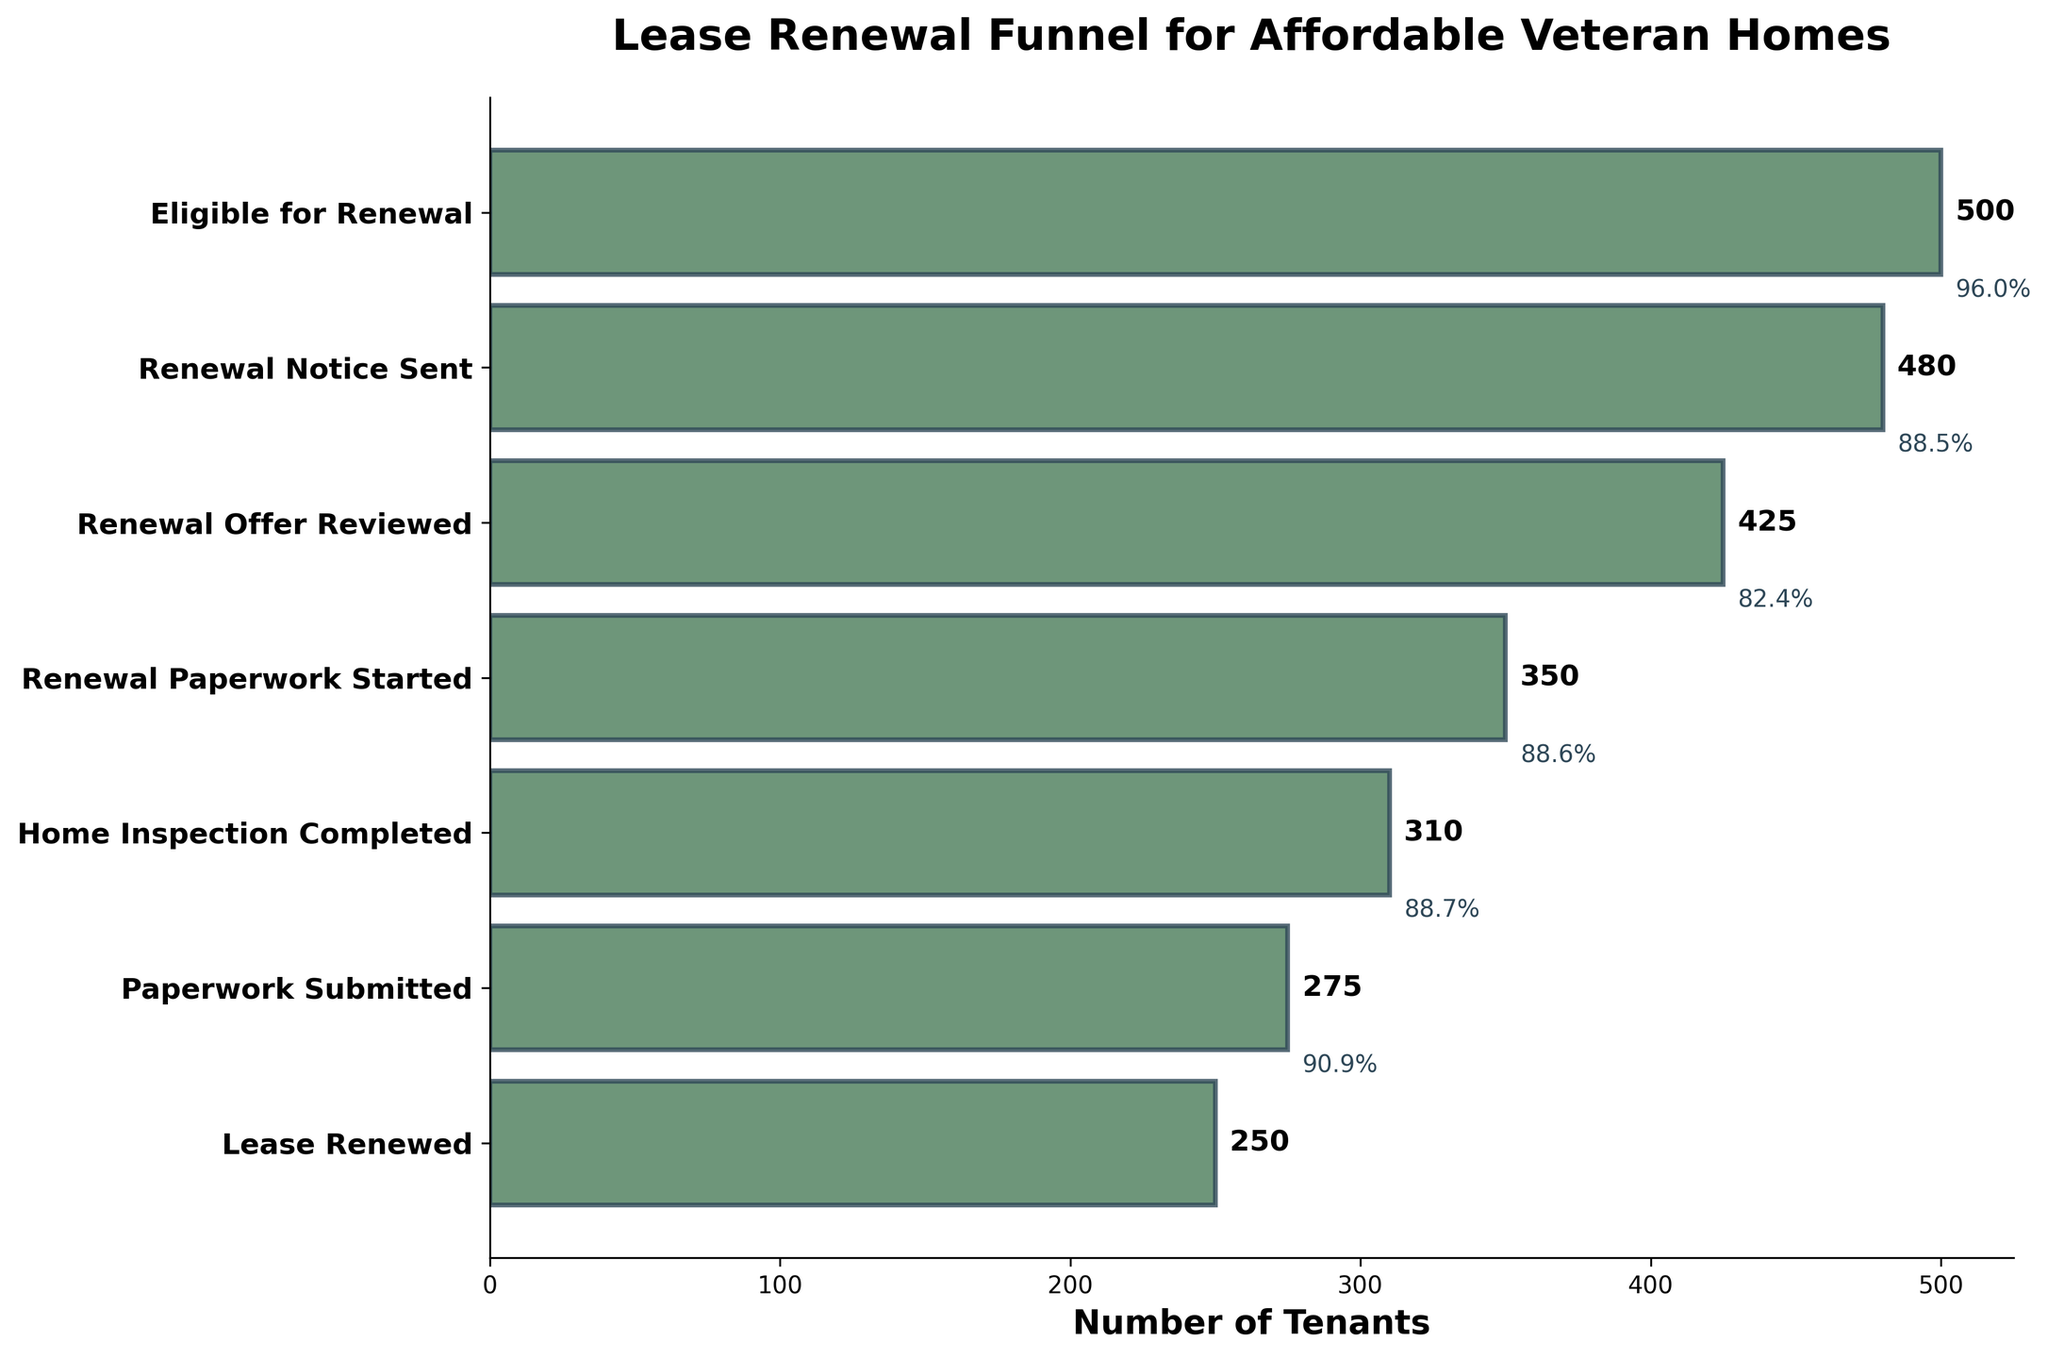What's the title of the figure? The title is usually displayed at the top of the figure. In this case, it reads "Lease Renewal Funnel for Affordable Veteran Homes" based on the provided code.
Answer: Lease Renewal Funnel for Affordable Veteran Homes How many tenants started the renewal paperwork? The figure shows multiple stages with the number of tenants in each stage. The number for "Renewal Paperwork Started" can be found and identified as 350 tenants.
Answer: 350 How many tenants received a renewal notice? The figure lists "Renewal Notice Sent" as one of the stages. The number of tenants at this stage is shown as 480.
Answer: 480 What percentage of eligible tenants had their paperwork submitted? Calculate the percentage by dividing the number of tenants who submitted paperwork by the number of eligible tenants and then multiplying by 100. (275 / 500) * 100 = 55%
Answer: 55% What is the decrease in the number of tenants between the "Home Inspection Completed" and "Paperwork Submitted" stages? To find the decrease, subtract the number of tenants who submitted paperwork from the number who completed the home inspection: 310 - 275 = 35.
Answer: 35 Which stage saw the highest drop-off in the number of tenants from the previous stage? Compare the differences between each consecutive stage: Eligible for Renewal to Renewal Notice Sent (20), Renewal Notice Sent to Renewal Offer Reviewed (55), etc. The largest drop from one stage to the next can be seen between "Renewal Offer Reviewed" to "Renewal Paperwork Started" with a drop of 75 tenants.
Answer: Renewal Offer Reviewed to Renewal Paperwork Started What's the total number of tenants from "Paperwork Submitted" to "Lease Renewed"? Sum the number of tenants who completed the stages from "Paperwork Submitted" to "Lease Renewed": 275 + 250 = 525.
Answer: 525 By what percentage did the number of tenants decrease from "Renewal Paperwork Started" to "Home Inspection Completed"? Calculate the percentage decrease: (1 - (310 / 350)) * 100 = 11.4%.
Answer: 11.4% Between which stages did tenants drop from 480 to 425? Identify the stages with the drop from 480 to 425. These are "Renewal Notice Sent" (480) and "Renewal Offer Reviewed" (425).
Answer: Renewal Notice Sent to Renewal Offer Reviewed What proportion of tenants who renewed their lease had completed the home inspection? Divide the number of tenants who renewed their lease by those who completed the home inspection and multiply by 100: (250 / 310) * 100 ≈ 80.6%.
Answer: 80.6% 